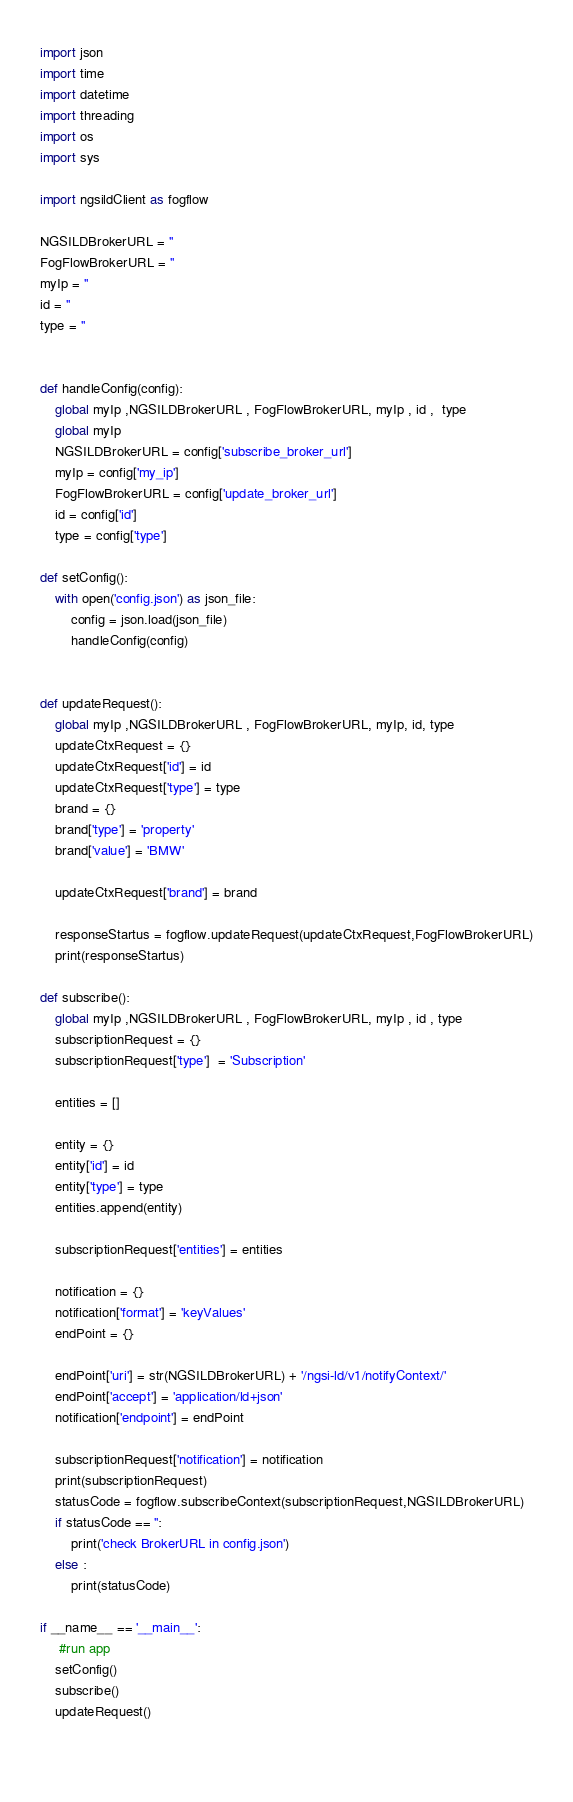<code> <loc_0><loc_0><loc_500><loc_500><_Python_>import json
import time
import datetime
import threading
import os
import sys

import ngsildClient as fogflow

NGSILDBrokerURL = ''
FogFlowBrokerURL = ''
myIp = ''
id = ''
type = ''


def handleConfig(config):
    global myIp ,NGSILDBrokerURL , FogFlowBrokerURL, myIp , id ,  type
    global myIp
    NGSILDBrokerURL = config['subscribe_broker_url']
    myIp = config['my_ip']
    FogFlowBrokerURL = config['update_broker_url']
    id = config['id']
    type = config['type']

def setConfig():
    with open('config.json') as json_file:
        config = json.load(json_file)
        handleConfig(config)


def updateRequest():
    global myIp ,NGSILDBrokerURL , FogFlowBrokerURL, myIp, id, type
    updateCtxRequest = {}
    updateCtxRequest['id'] = id
    updateCtxRequest['type'] = type
    brand = {}
    brand['type'] = 'property'
    brand['value'] = 'BMW'
    
    updateCtxRequest['brand'] = brand 

    responseStartus = fogflow.updateRequest(updateCtxRequest,FogFlowBrokerURL)
    print(responseStartus)

def subscribe():
    global myIp ,NGSILDBrokerURL , FogFlowBrokerURL, myIp , id , type
    subscriptionRequest = {}
    subscriptionRequest['type']  = 'Subscription'

    entities = []

    entity = {}
    entity['id'] = id
    entity['type'] = type
    entities.append(entity)

    subscriptionRequest['entities'] = entities

    notification = {}
    notification['format'] = 'keyValues'
    endPoint = {}

    endPoint['uri'] = str(NGSILDBrokerURL) + '/ngsi-ld/v1/notifyContext/'
    endPoint['accept'] = 'application/ld+json'
    notification['endpoint'] = endPoint

    subscriptionRequest['notification'] = notification
    print(subscriptionRequest)
    statusCode = fogflow.subscribeContext(subscriptionRequest,NGSILDBrokerURL)
    if statusCode == '':
        print('check BrokerURL in config.json')
    else :
        print(statusCode)
    
if __name__ == '__main__':
     #run app
    setConfig()
    subscribe()
    updateRequest()
    
     

</code> 